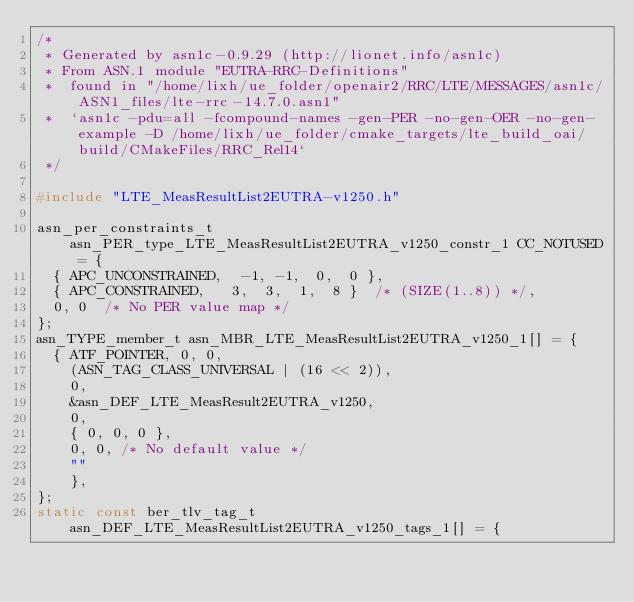Convert code to text. <code><loc_0><loc_0><loc_500><loc_500><_C_>/*
 * Generated by asn1c-0.9.29 (http://lionet.info/asn1c)
 * From ASN.1 module "EUTRA-RRC-Definitions"
 * 	found in "/home/lixh/ue_folder/openair2/RRC/LTE/MESSAGES/asn1c/ASN1_files/lte-rrc-14.7.0.asn1"
 * 	`asn1c -pdu=all -fcompound-names -gen-PER -no-gen-OER -no-gen-example -D /home/lixh/ue_folder/cmake_targets/lte_build_oai/build/CMakeFiles/RRC_Rel14`
 */

#include "LTE_MeasResultList2EUTRA-v1250.h"

asn_per_constraints_t asn_PER_type_LTE_MeasResultList2EUTRA_v1250_constr_1 CC_NOTUSED = {
	{ APC_UNCONSTRAINED,	-1, -1,  0,  0 },
	{ APC_CONSTRAINED,	 3,  3,  1,  8 }	/* (SIZE(1..8)) */,
	0, 0	/* No PER value map */
};
asn_TYPE_member_t asn_MBR_LTE_MeasResultList2EUTRA_v1250_1[] = {
	{ ATF_POINTER, 0, 0,
		(ASN_TAG_CLASS_UNIVERSAL | (16 << 2)),
		0,
		&asn_DEF_LTE_MeasResult2EUTRA_v1250,
		0,
		{ 0, 0, 0 },
		0, 0, /* No default value */
		""
		},
};
static const ber_tlv_tag_t asn_DEF_LTE_MeasResultList2EUTRA_v1250_tags_1[] = {</code> 